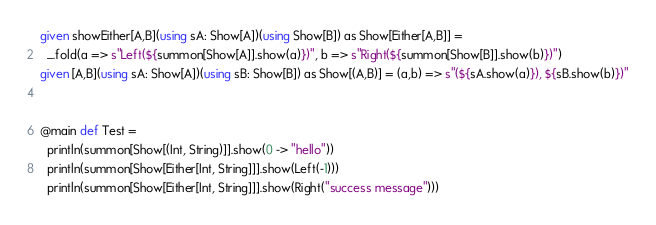<code> <loc_0><loc_0><loc_500><loc_500><_Scala_>given showEither[A,B](using sA: Show[A])(using Show[B]) as Show[Either[A,B]] =
  _.fold(a => s"Left(${summon[Show[A]].show(a)})", b => s"Right(${summon[Show[B]].show(b)})")
given [A,B](using sA: Show[A])(using sB: Show[B]) as Show[(A,B)] = (a,b) => s"(${sA.show(a)}), ${sB.show(b)})"


@main def Test =
  println(summon[Show[(Int, String)]].show(0 -> "hello"))
  println(summon[Show[Either[Int, String]]].show(Left(-1)))
  println(summon[Show[Either[Int, String]]].show(Right("success message")))
</code> 